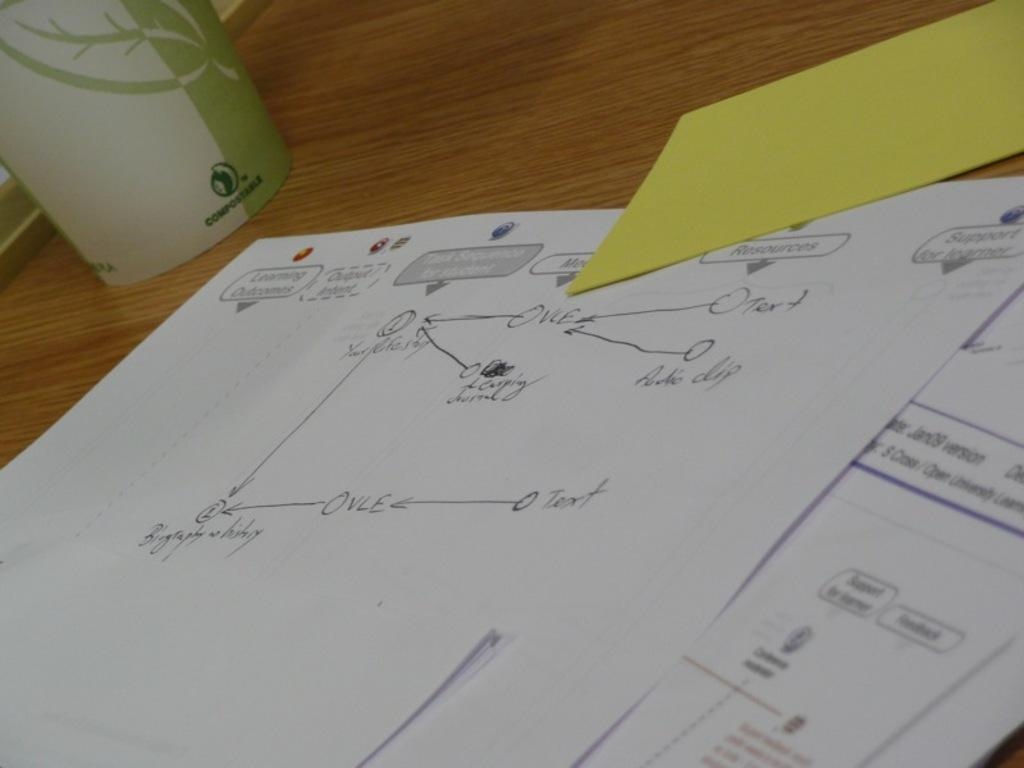<image>
Summarize the visual content of the image. A "compostable" paper cup sits next to some blueprint drawings on a wooden surface. 